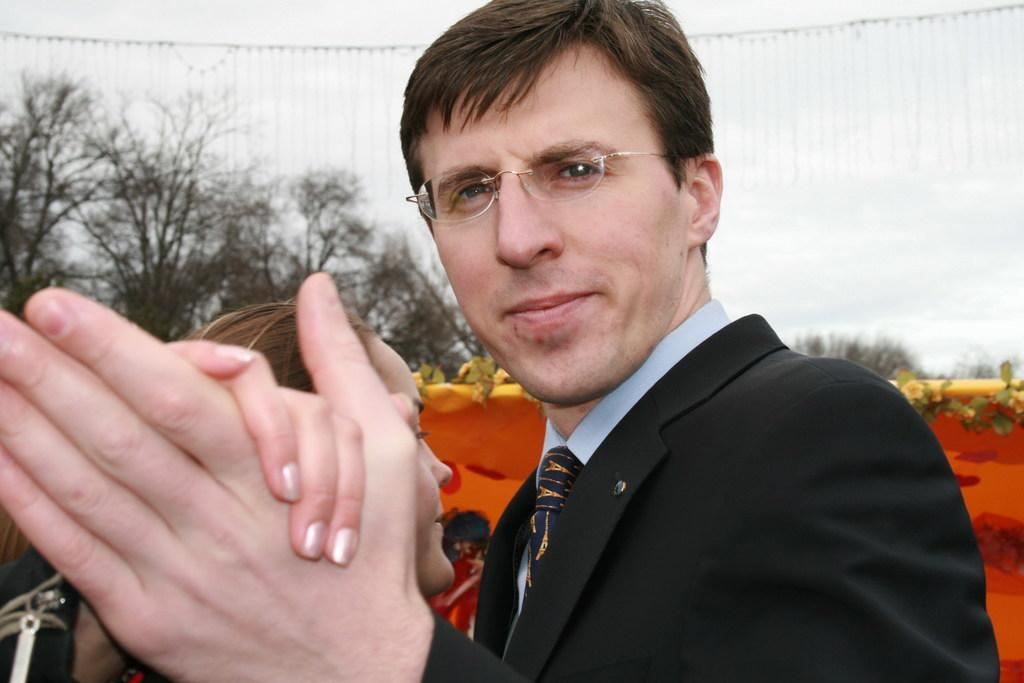How many people are in the image? There is a man and a woman in the image. What are the positions of the man and woman in the image? The man and woman are both standing in the image. What is the man wearing in the image? The man is wearing a shirt, tie, and suit in the image. What type of natural elements can be seen in the image? There are trees and flowers with leaves in the image. What type of material is visible in the image? There is a cloth visible in the image. How many toes can be seen on the person in the image? There is no person in the image; there are only a man and a woman, both of whom are fully clothed and not showing their toes. 